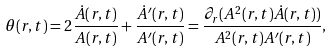<formula> <loc_0><loc_0><loc_500><loc_500>\theta ( r , t ) = 2 \frac { \dot { A } ( r , t ) } { A ( r , t ) } + \frac { \dot { A } ^ { \prime } ( r , t ) } { A ^ { \prime } ( r , t ) } = \frac { \partial _ { r } ( A ^ { 2 } ( r , t ) \dot { A } ( r , t ) ) } { A ^ { 2 } ( r , t ) A ^ { \prime } ( r , t ) } ,</formula> 